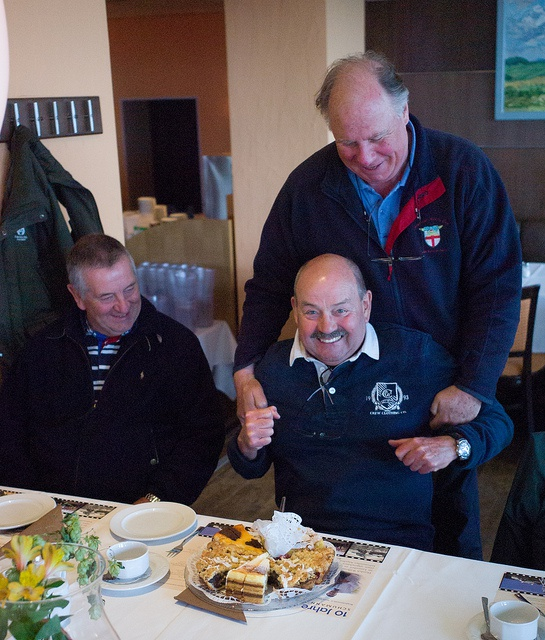Describe the objects in this image and their specific colors. I can see dining table in lightgray, darkgray, and tan tones, people in lightgray, black, navy, brown, and darkgray tones, people in lightgray, black, navy, brown, and darkgray tones, people in lightgray, black, purple, brown, and maroon tones, and vase in lightgray, darkgray, teal, and darkgreen tones in this image. 